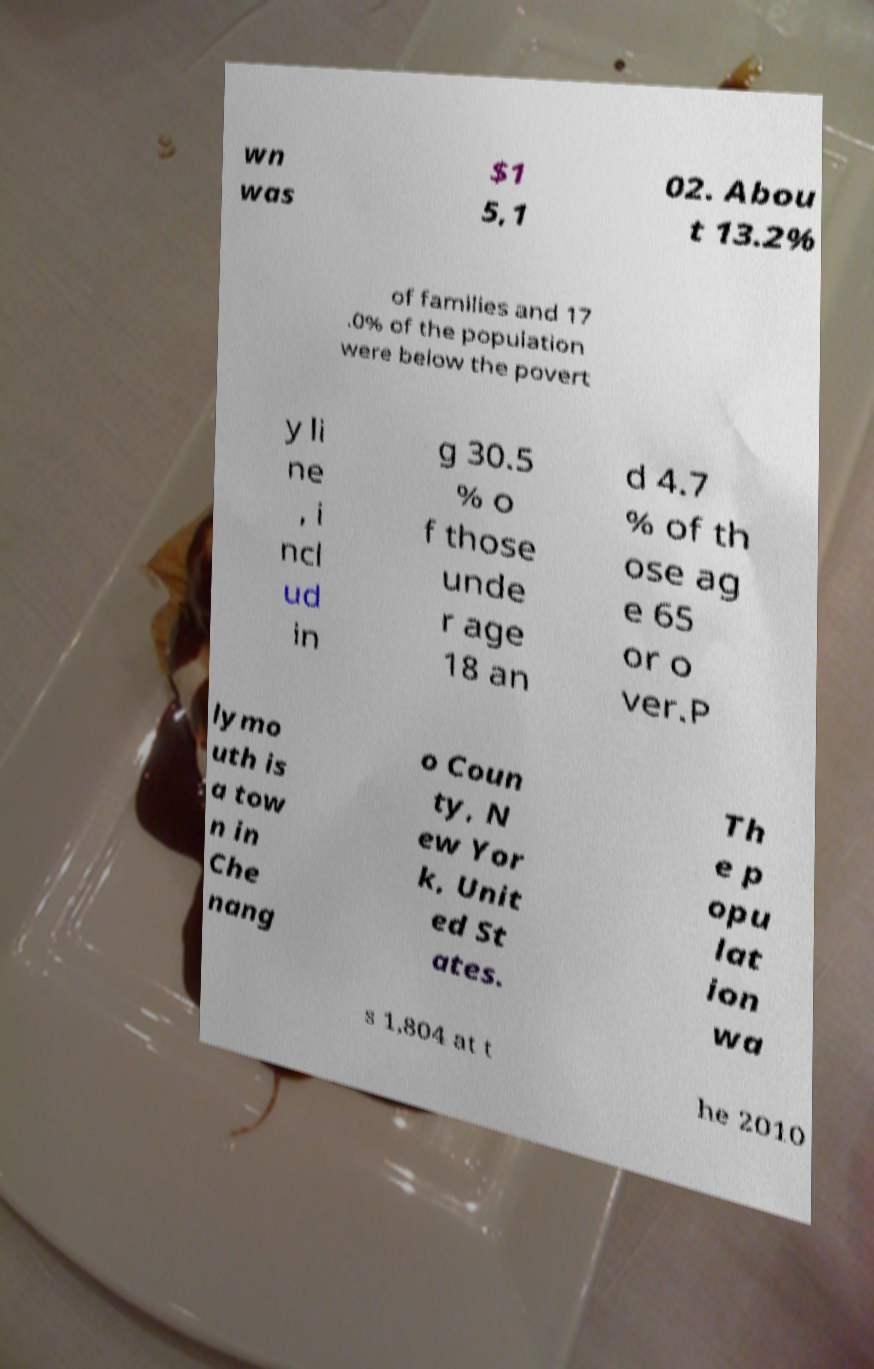There's text embedded in this image that I need extracted. Can you transcribe it verbatim? wn was $1 5,1 02. Abou t 13.2% of families and 17 .0% of the population were below the povert y li ne , i ncl ud in g 30.5 % o f those unde r age 18 an d 4.7 % of th ose ag e 65 or o ver.P lymo uth is a tow n in Che nang o Coun ty, N ew Yor k, Unit ed St ates. Th e p opu lat ion wa s 1,804 at t he 2010 